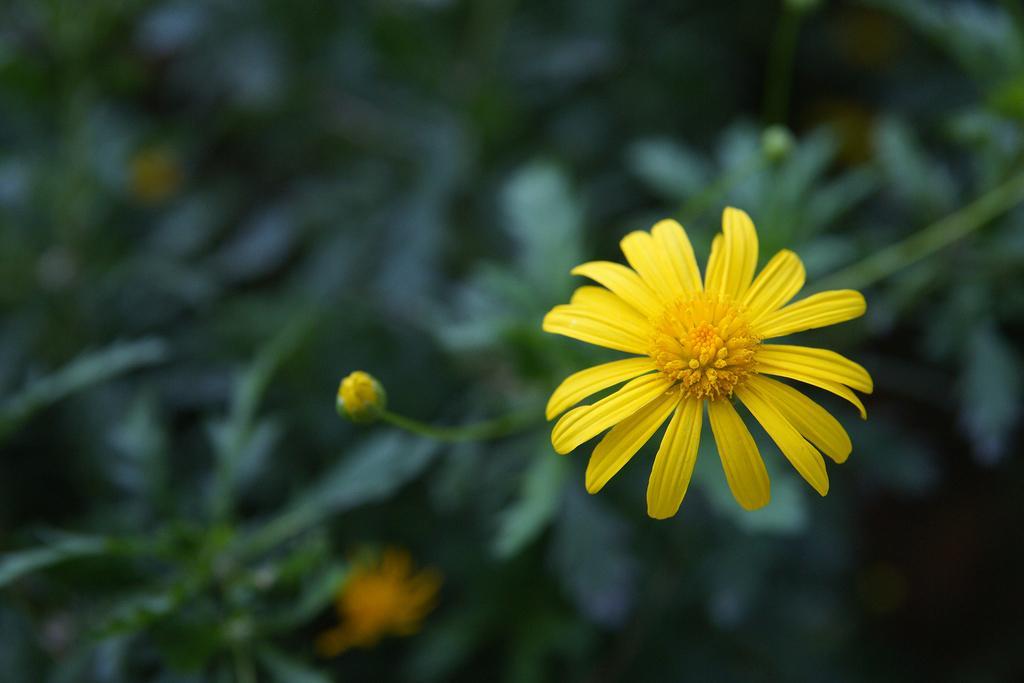How would you summarize this image in a sentence or two? In this image I can see a yellow color flower. Background is in green color. 